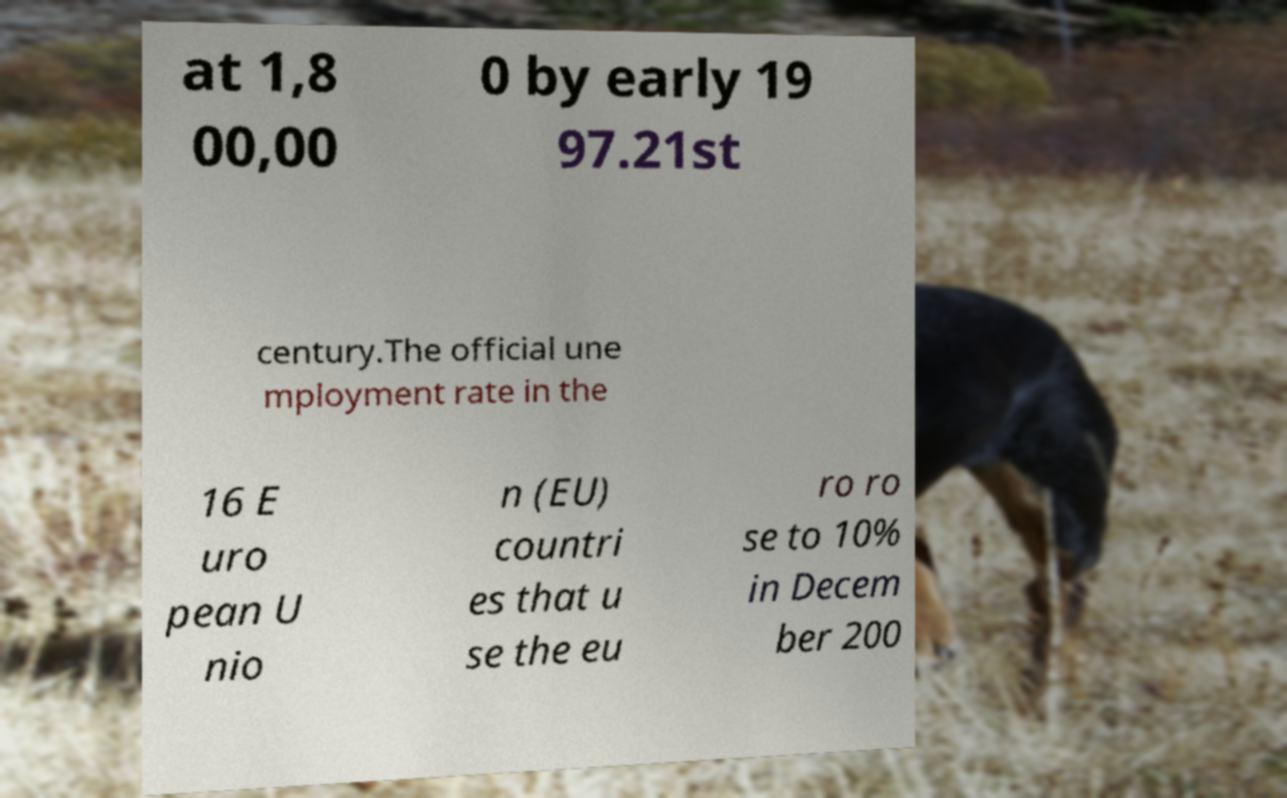Can you read and provide the text displayed in the image?This photo seems to have some interesting text. Can you extract and type it out for me? at 1,8 00,00 0 by early 19 97.21st century.The official une mployment rate in the 16 E uro pean U nio n (EU) countri es that u se the eu ro ro se to 10% in Decem ber 200 